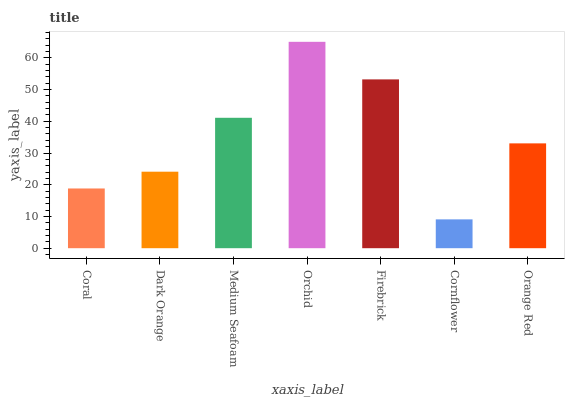Is Cornflower the minimum?
Answer yes or no. Yes. Is Orchid the maximum?
Answer yes or no. Yes. Is Dark Orange the minimum?
Answer yes or no. No. Is Dark Orange the maximum?
Answer yes or no. No. Is Dark Orange greater than Coral?
Answer yes or no. Yes. Is Coral less than Dark Orange?
Answer yes or no. Yes. Is Coral greater than Dark Orange?
Answer yes or no. No. Is Dark Orange less than Coral?
Answer yes or no. No. Is Orange Red the high median?
Answer yes or no. Yes. Is Orange Red the low median?
Answer yes or no. Yes. Is Cornflower the high median?
Answer yes or no. No. Is Coral the low median?
Answer yes or no. No. 